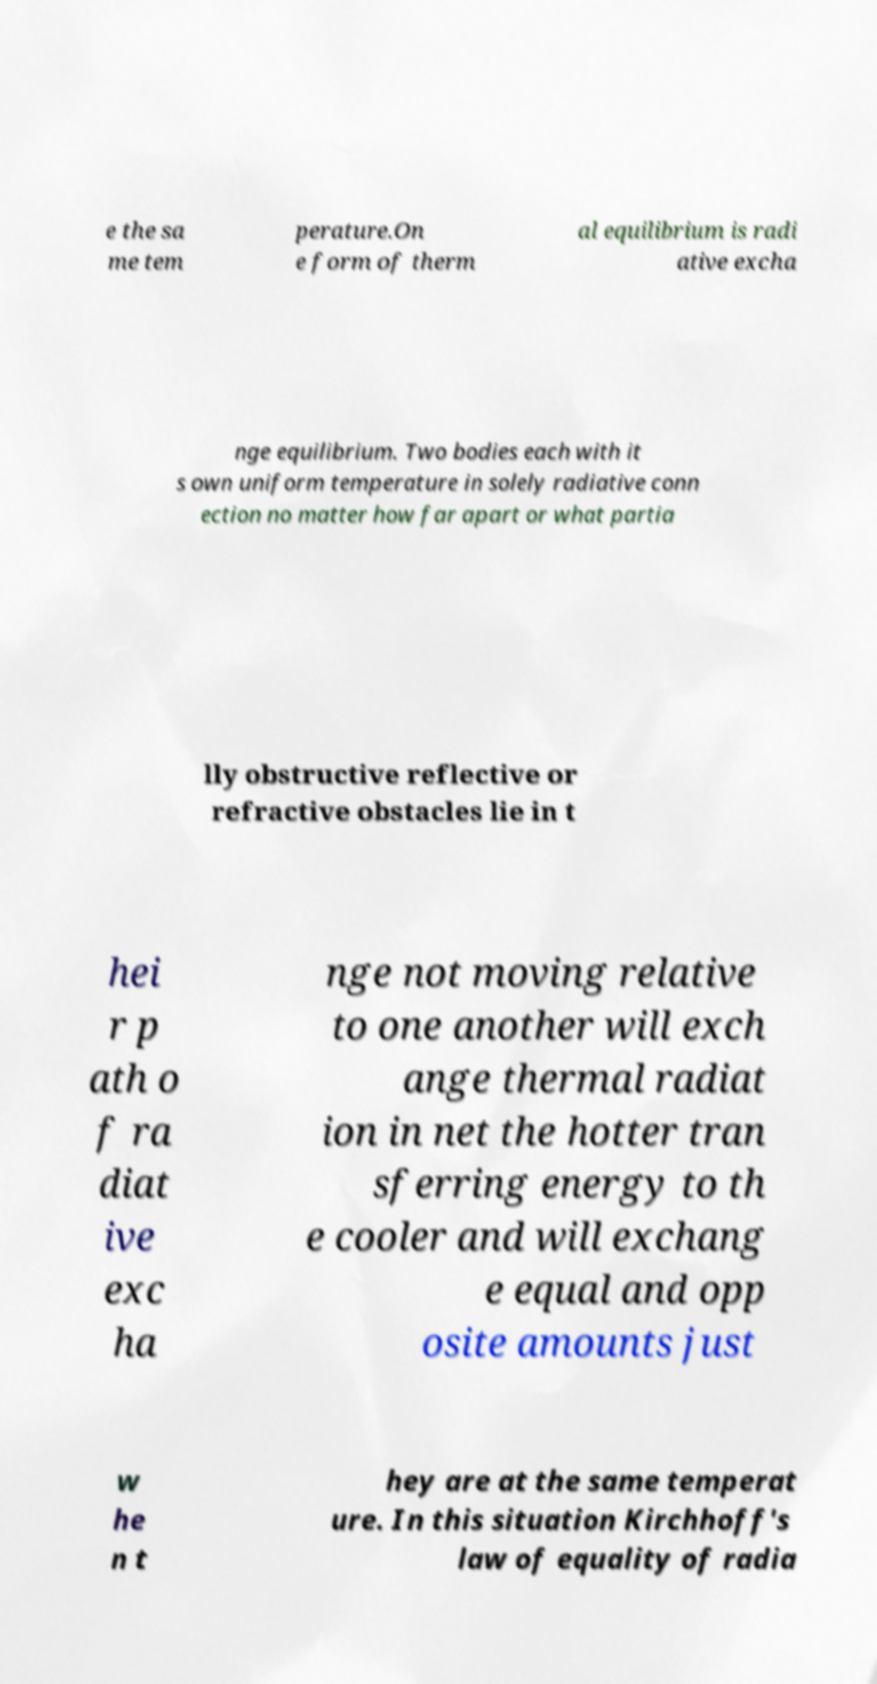Please read and relay the text visible in this image. What does it say? e the sa me tem perature.On e form of therm al equilibrium is radi ative excha nge equilibrium. Two bodies each with it s own uniform temperature in solely radiative conn ection no matter how far apart or what partia lly obstructive reflective or refractive obstacles lie in t hei r p ath o f ra diat ive exc ha nge not moving relative to one another will exch ange thermal radiat ion in net the hotter tran sferring energy to th e cooler and will exchang e equal and opp osite amounts just w he n t hey are at the same temperat ure. In this situation Kirchhoff's law of equality of radia 